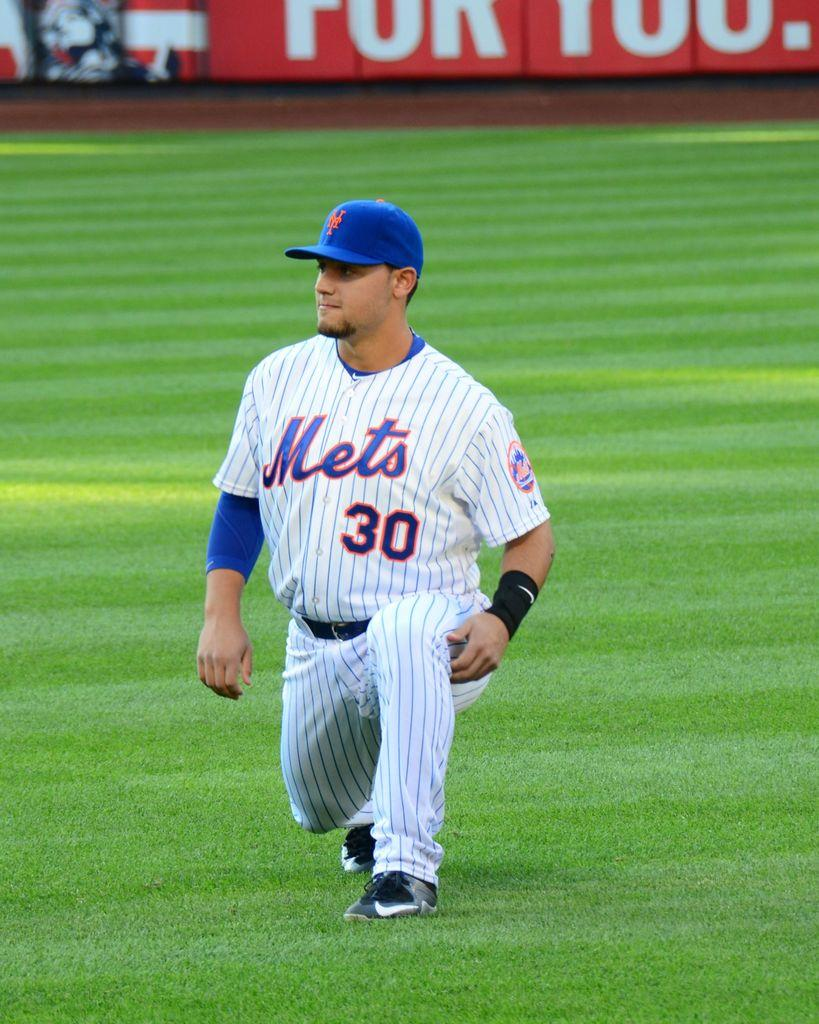<image>
Write a terse but informative summary of the picture. A Mets baseball player is wearing number 30. 